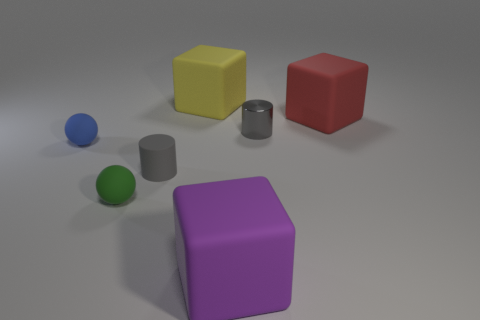Add 2 purple things. How many objects exist? 9 Subtract all balls. How many objects are left? 5 Add 6 purple shiny things. How many purple shiny things exist? 6 Subtract 1 purple cubes. How many objects are left? 6 Subtract all blocks. Subtract all large red blocks. How many objects are left? 3 Add 7 blocks. How many blocks are left? 10 